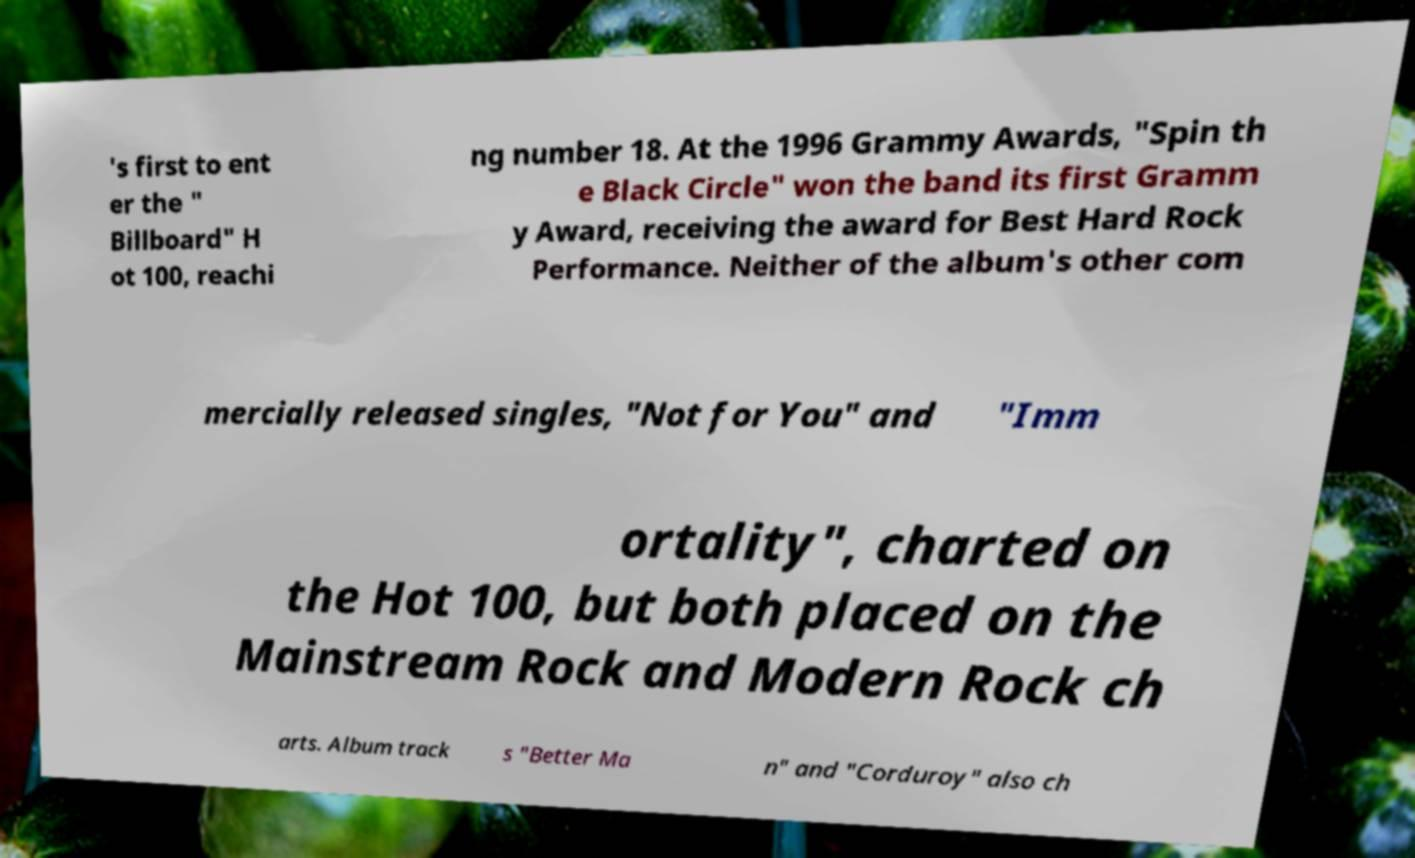For documentation purposes, I need the text within this image transcribed. Could you provide that? 's first to ent er the " Billboard" H ot 100, reachi ng number 18. At the 1996 Grammy Awards, "Spin th e Black Circle" won the band its first Gramm y Award, receiving the award for Best Hard Rock Performance. Neither of the album's other com mercially released singles, "Not for You" and "Imm ortality", charted on the Hot 100, but both placed on the Mainstream Rock and Modern Rock ch arts. Album track s "Better Ma n" and "Corduroy" also ch 